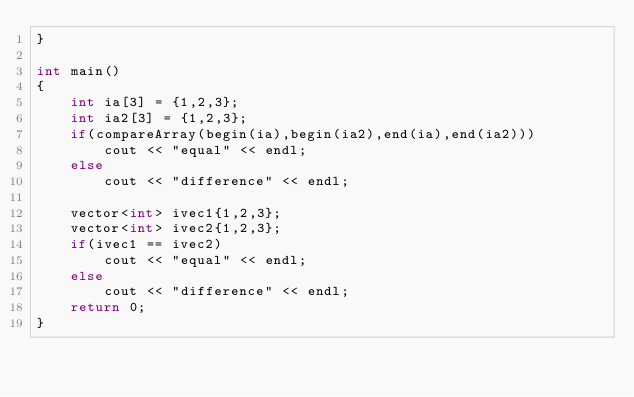<code> <loc_0><loc_0><loc_500><loc_500><_C++_>}

int main()
{
    int ia[3] = {1,2,3};
    int ia2[3] = {1,2,3};
    if(compareArray(begin(ia),begin(ia2),end(ia),end(ia2)))
        cout << "equal" << endl;
    else
        cout << "difference" << endl;

    vector<int> ivec1{1,2,3};
    vector<int> ivec2{1,2,3};
    if(ivec1 == ivec2)
        cout << "equal" << endl;
    else
        cout << "difference" << endl;
    return 0;
}</code> 